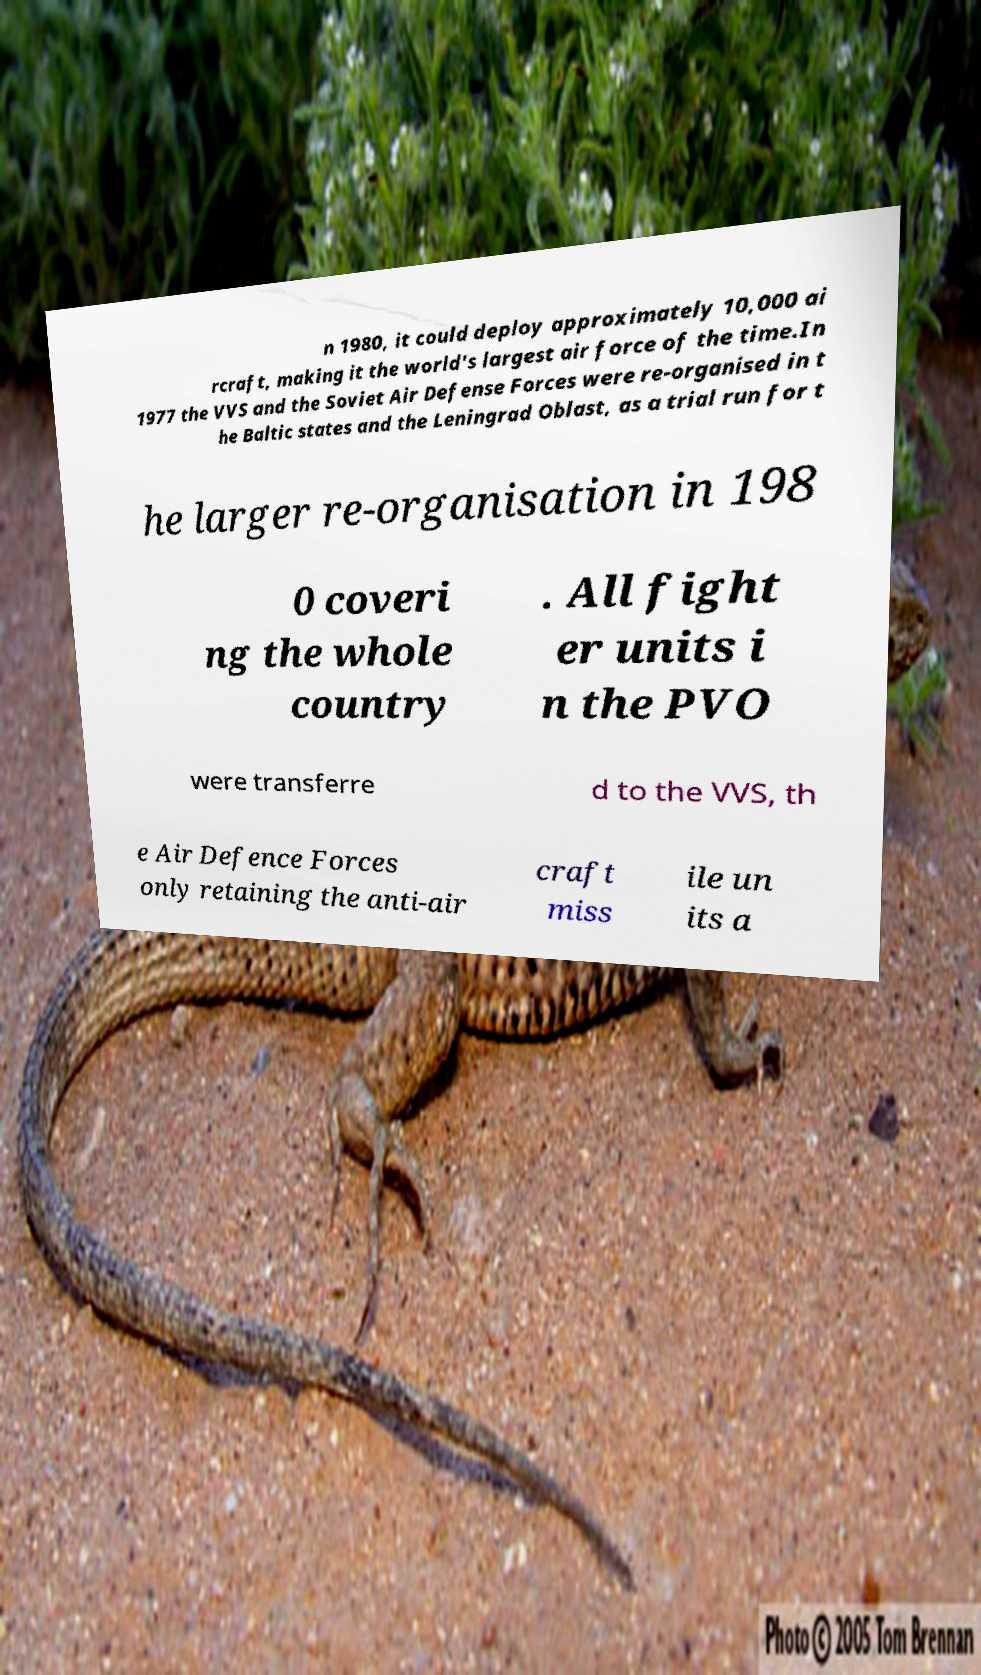Can you read and provide the text displayed in the image?This photo seems to have some interesting text. Can you extract and type it out for me? n 1980, it could deploy approximately 10,000 ai rcraft, making it the world's largest air force of the time.In 1977 the VVS and the Soviet Air Defense Forces were re-organised in t he Baltic states and the Leningrad Oblast, as a trial run for t he larger re-organisation in 198 0 coveri ng the whole country . All fight er units i n the PVO were transferre d to the VVS, th e Air Defence Forces only retaining the anti-air craft miss ile un its a 